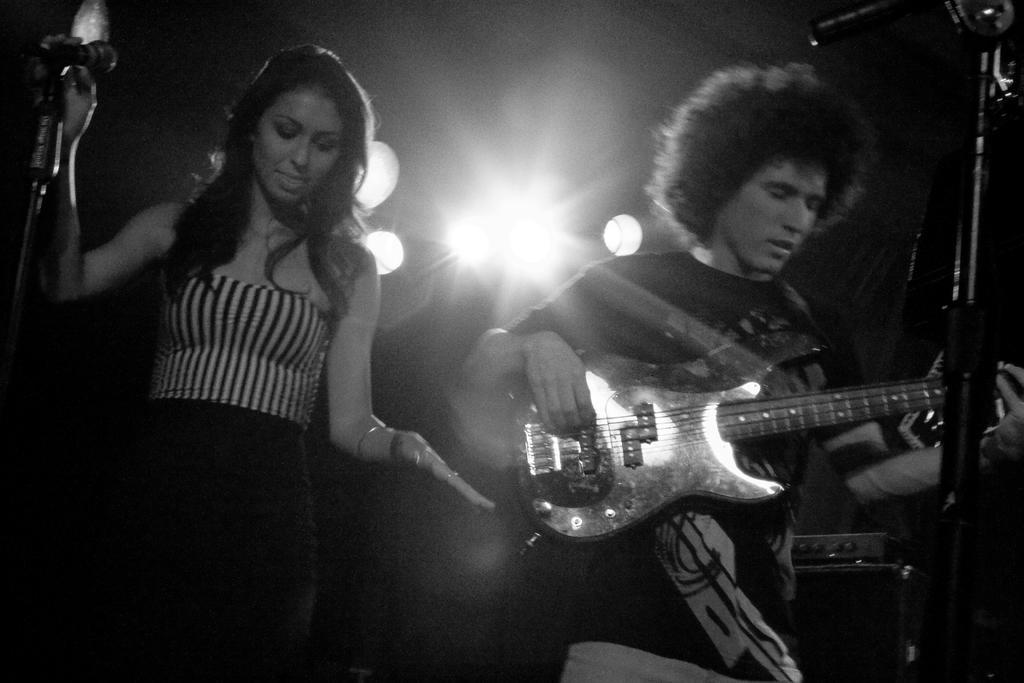Please provide a concise description of this image. In this picture we can see a woman and a man, a man is playing guitar in front of microphone, in the background we can see couple of lights. 